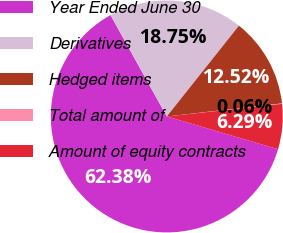<chart> <loc_0><loc_0><loc_500><loc_500><pie_chart><fcel>Year Ended June 30<fcel>Derivatives<fcel>Hedged items<fcel>Total amount of<fcel>Amount of equity contracts<nl><fcel>62.37%<fcel>18.75%<fcel>12.52%<fcel>0.06%<fcel>6.29%<nl></chart> 